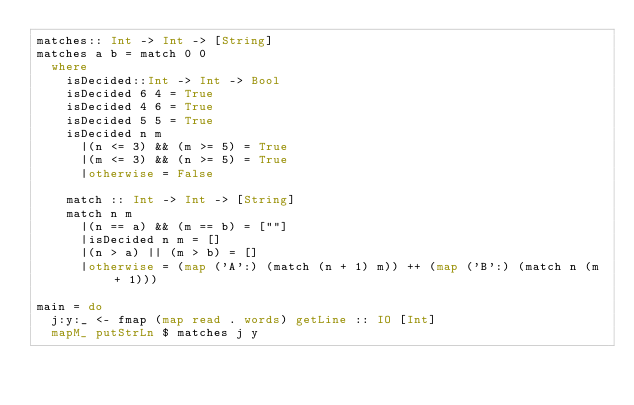<code> <loc_0><loc_0><loc_500><loc_500><_Haskell_>matches:: Int -> Int -> [String]
matches a b = match 0 0
  where
    isDecided::Int -> Int -> Bool
    isDecided 6 4 = True
    isDecided 4 6 = True
    isDecided 5 5 = True
    isDecided n m
      |(n <= 3) && (m >= 5) = True
      |(m <= 3) && (n >= 5) = True
      |otherwise = False

    match :: Int -> Int -> [String]
    match n m
      |(n == a) && (m == b) = [""]
      |isDecided n m = []
      |(n > a) || (m > b) = []
      |otherwise = (map ('A':) (match (n + 1) m)) ++ (map ('B':) (match n (m + 1)))

main = do
  j:y:_ <- fmap (map read . words) getLine :: IO [Int]
  mapM_ putStrLn $ matches j y
</code> 